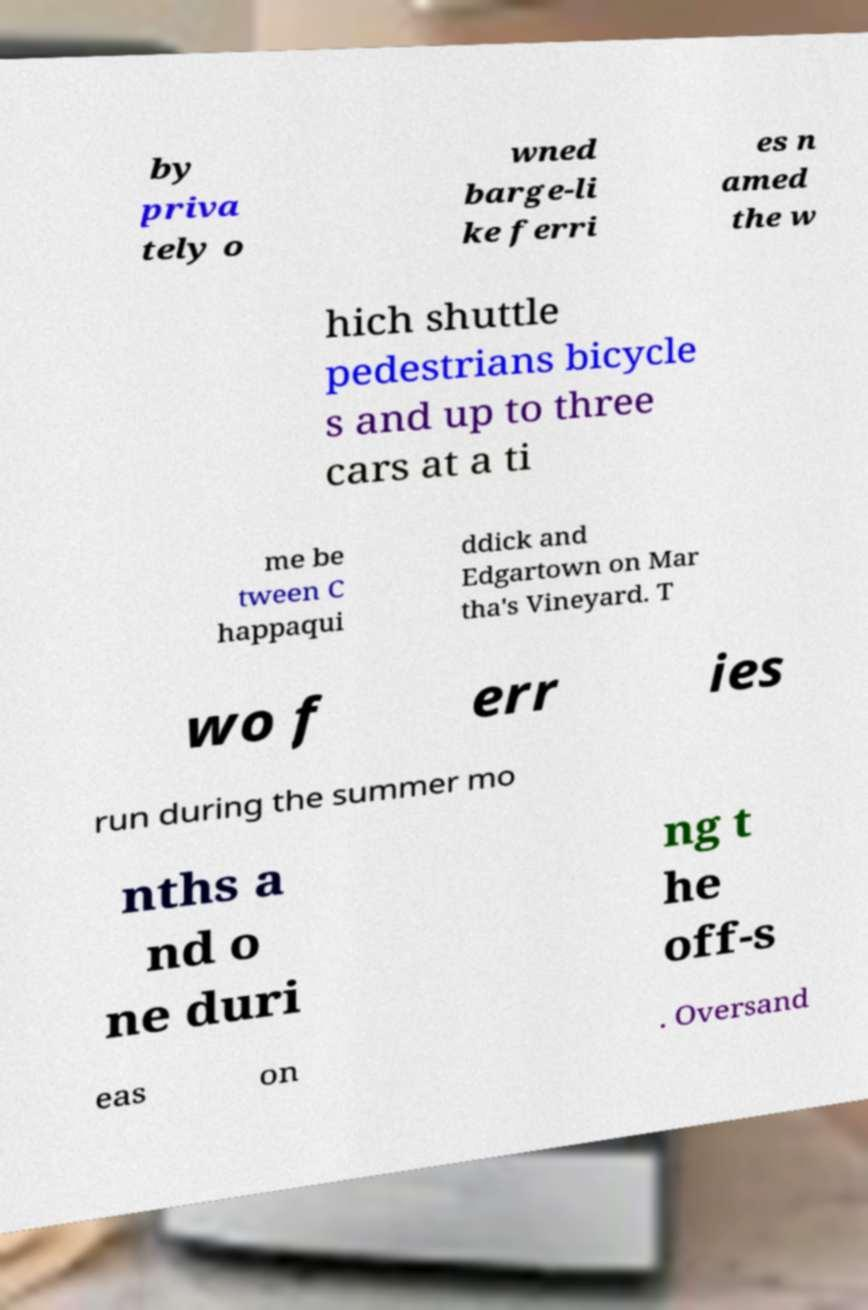Please read and relay the text visible in this image. What does it say? by priva tely o wned barge-li ke ferri es n amed the w hich shuttle pedestrians bicycle s and up to three cars at a ti me be tween C happaqui ddick and Edgartown on Mar tha's Vineyard. T wo f err ies run during the summer mo nths a nd o ne duri ng t he off-s eas on . Oversand 